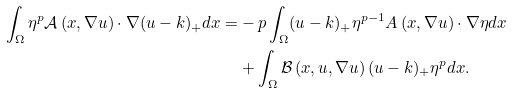<formula> <loc_0><loc_0><loc_500><loc_500>\int _ { \Omega } \eta ^ { p } \mathcal { A } \left ( x , \nabla u \right ) \cdot \nabla ( u - k ) _ { + } d x = & - p \int _ { \Omega } ( u - k ) _ { + } \eta ^ { p - 1 } A \left ( x , \nabla u \right ) \cdot \nabla \eta d x \\ & + \int _ { \Omega } \mathcal { B } \left ( x , u , \nabla u \right ) ( u - k ) _ { + } \eta ^ { p } d x .</formula> 